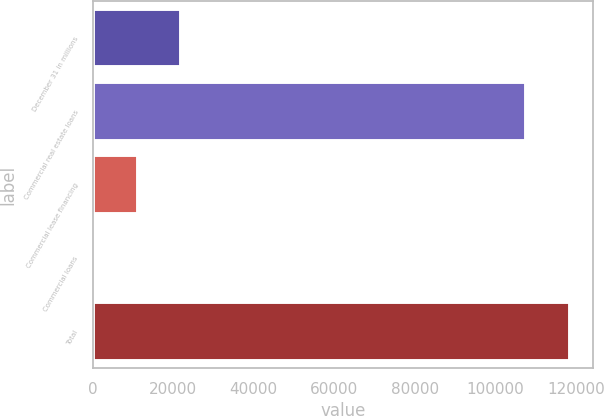Convert chart to OTSL. <chart><loc_0><loc_0><loc_500><loc_500><bar_chart><fcel>December 31 in millions<fcel>Commercial real estate loans<fcel>Commercial lease financing<fcel>Commercial loans<fcel>Total<nl><fcel>21973<fcel>107630<fcel>11158<fcel>343<fcel>118445<nl></chart> 